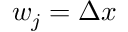<formula> <loc_0><loc_0><loc_500><loc_500>w _ { j } = \Delta x</formula> 